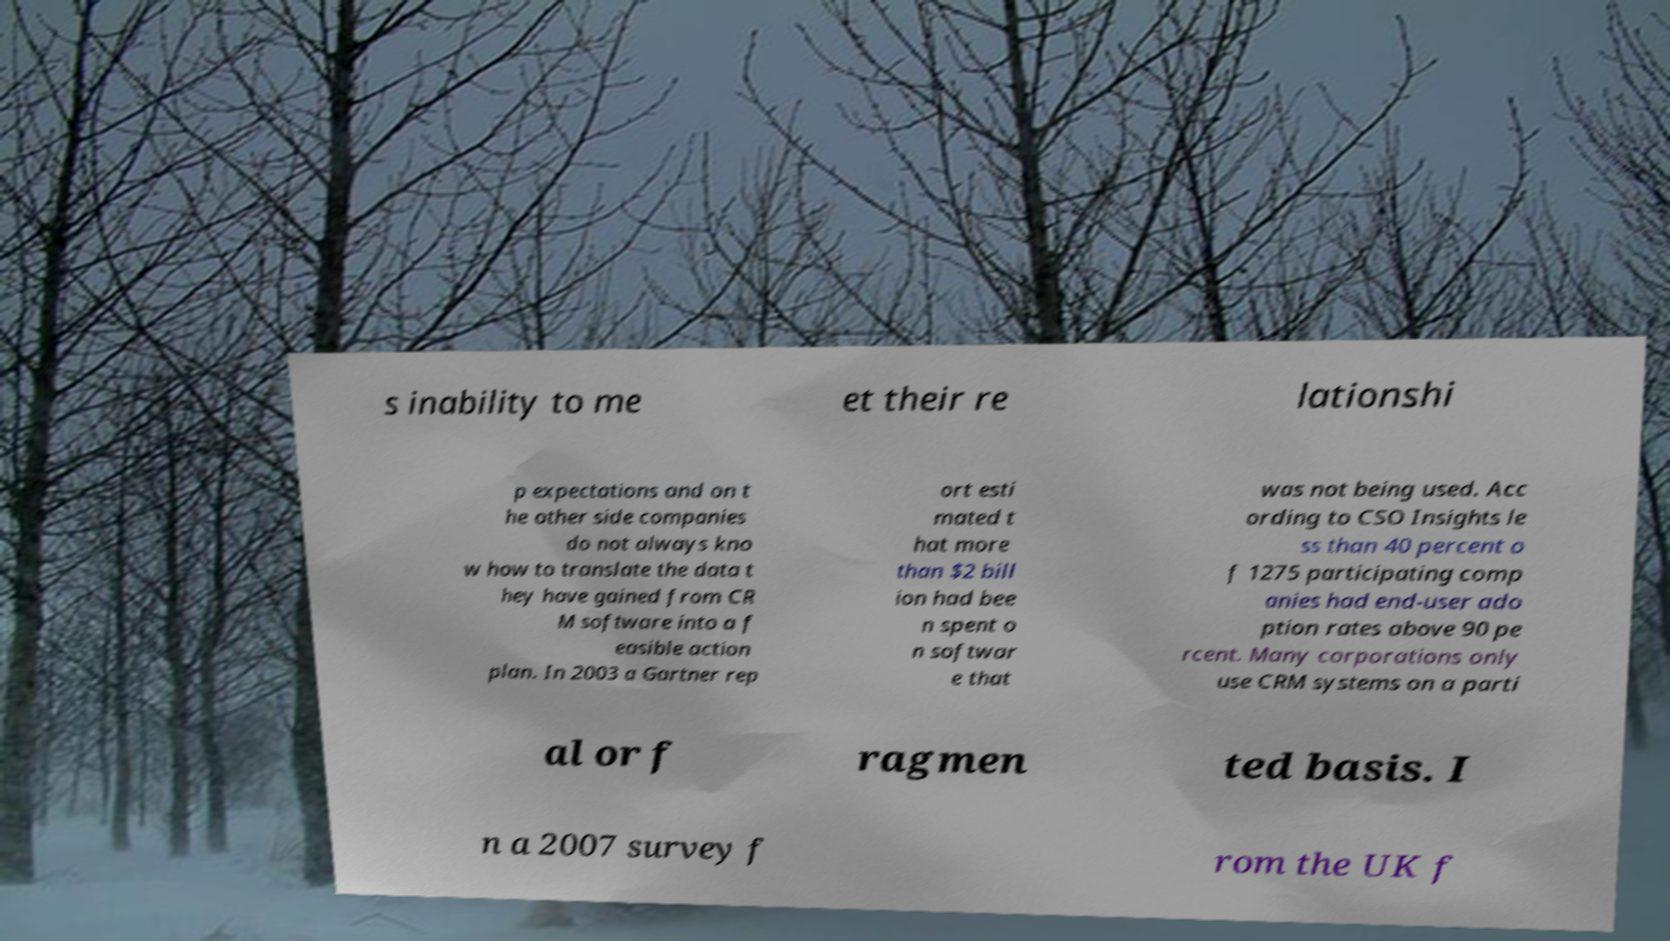Can you accurately transcribe the text from the provided image for me? s inability to me et their re lationshi p expectations and on t he other side companies do not always kno w how to translate the data t hey have gained from CR M software into a f easible action plan. In 2003 a Gartner rep ort esti mated t hat more than $2 bill ion had bee n spent o n softwar e that was not being used. Acc ording to CSO Insights le ss than 40 percent o f 1275 participating comp anies had end-user ado ption rates above 90 pe rcent. Many corporations only use CRM systems on a parti al or f ragmen ted basis. I n a 2007 survey f rom the UK f 